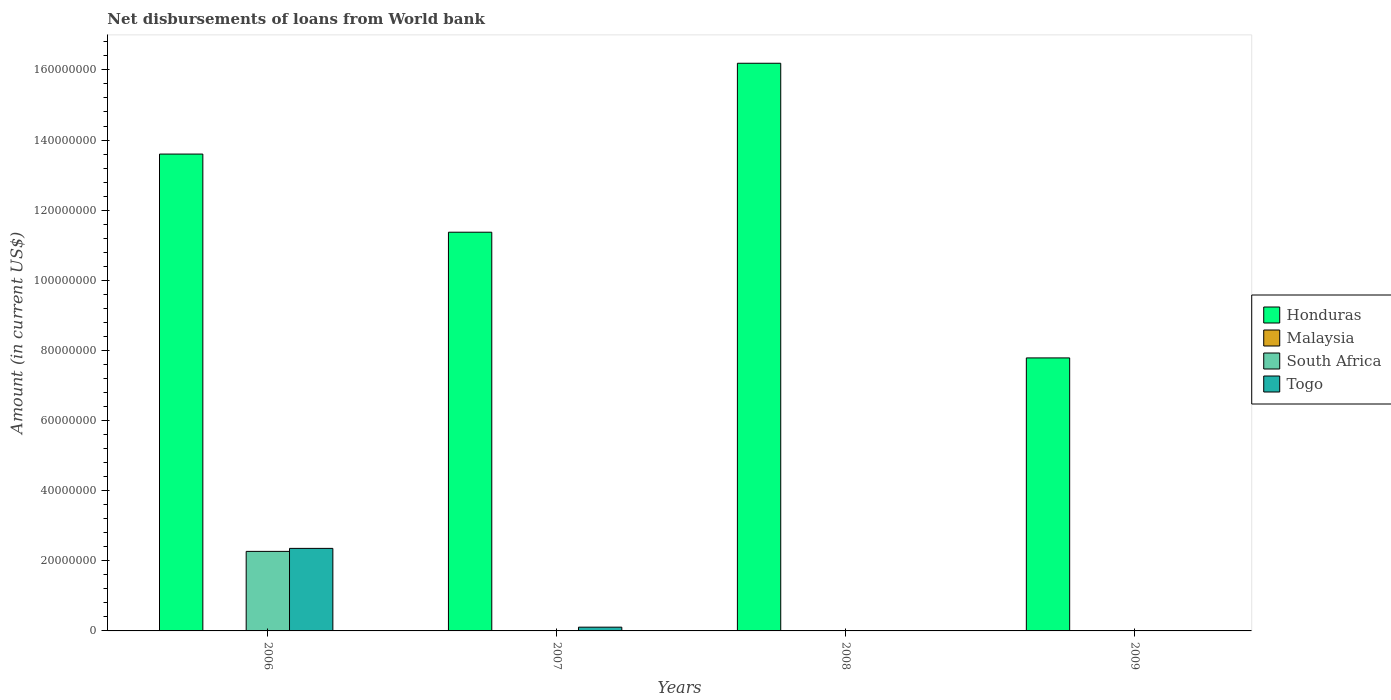Are the number of bars per tick equal to the number of legend labels?
Your answer should be compact. No. Are the number of bars on each tick of the X-axis equal?
Give a very brief answer. No. What is the label of the 1st group of bars from the left?
Keep it short and to the point. 2006. In how many cases, is the number of bars for a given year not equal to the number of legend labels?
Give a very brief answer. 4. What is the amount of loan disbursed from World Bank in Togo in 2008?
Offer a very short reply. 0. Across all years, what is the maximum amount of loan disbursed from World Bank in Honduras?
Keep it short and to the point. 1.62e+08. Across all years, what is the minimum amount of loan disbursed from World Bank in Honduras?
Make the answer very short. 7.79e+07. In which year was the amount of loan disbursed from World Bank in South Africa maximum?
Your answer should be compact. 2006. What is the total amount of loan disbursed from World Bank in Malaysia in the graph?
Offer a very short reply. 0. What is the difference between the amount of loan disbursed from World Bank in Honduras in 2006 and that in 2008?
Keep it short and to the point. -2.59e+07. What is the difference between the amount of loan disbursed from World Bank in Honduras in 2007 and the amount of loan disbursed from World Bank in Malaysia in 2008?
Your answer should be very brief. 1.14e+08. In the year 2006, what is the difference between the amount of loan disbursed from World Bank in South Africa and amount of loan disbursed from World Bank in Togo?
Offer a very short reply. -8.56e+05. What is the difference between the highest and the lowest amount of loan disbursed from World Bank in Togo?
Make the answer very short. 2.35e+07. Is the sum of the amount of loan disbursed from World Bank in Honduras in 2008 and 2009 greater than the maximum amount of loan disbursed from World Bank in South Africa across all years?
Make the answer very short. Yes. Is it the case that in every year, the sum of the amount of loan disbursed from World Bank in Togo and amount of loan disbursed from World Bank in South Africa is greater than the amount of loan disbursed from World Bank in Honduras?
Provide a succinct answer. No. How many bars are there?
Your answer should be very brief. 7. Are all the bars in the graph horizontal?
Your answer should be compact. No. How many years are there in the graph?
Offer a terse response. 4. What is the difference between two consecutive major ticks on the Y-axis?
Provide a short and direct response. 2.00e+07. How are the legend labels stacked?
Your response must be concise. Vertical. What is the title of the graph?
Offer a very short reply. Net disbursements of loans from World bank. What is the label or title of the X-axis?
Your answer should be compact. Years. What is the label or title of the Y-axis?
Ensure brevity in your answer.  Amount (in current US$). What is the Amount (in current US$) of Honduras in 2006?
Give a very brief answer. 1.36e+08. What is the Amount (in current US$) in South Africa in 2006?
Your answer should be compact. 2.27e+07. What is the Amount (in current US$) in Togo in 2006?
Provide a short and direct response. 2.35e+07. What is the Amount (in current US$) in Honduras in 2007?
Give a very brief answer. 1.14e+08. What is the Amount (in current US$) of Togo in 2007?
Your answer should be very brief. 1.07e+06. What is the Amount (in current US$) of Honduras in 2008?
Your answer should be compact. 1.62e+08. What is the Amount (in current US$) of Togo in 2008?
Offer a terse response. 0. What is the Amount (in current US$) in Honduras in 2009?
Keep it short and to the point. 7.79e+07. What is the Amount (in current US$) of Malaysia in 2009?
Offer a very short reply. 0. What is the Amount (in current US$) of South Africa in 2009?
Your response must be concise. 0. What is the Amount (in current US$) in Togo in 2009?
Your answer should be very brief. 0. Across all years, what is the maximum Amount (in current US$) of Honduras?
Offer a terse response. 1.62e+08. Across all years, what is the maximum Amount (in current US$) of South Africa?
Give a very brief answer. 2.27e+07. Across all years, what is the maximum Amount (in current US$) in Togo?
Your answer should be very brief. 2.35e+07. Across all years, what is the minimum Amount (in current US$) in Honduras?
Give a very brief answer. 7.79e+07. Across all years, what is the minimum Amount (in current US$) of South Africa?
Give a very brief answer. 0. What is the total Amount (in current US$) of Honduras in the graph?
Give a very brief answer. 4.89e+08. What is the total Amount (in current US$) in Malaysia in the graph?
Ensure brevity in your answer.  0. What is the total Amount (in current US$) of South Africa in the graph?
Provide a short and direct response. 2.27e+07. What is the total Amount (in current US$) of Togo in the graph?
Ensure brevity in your answer.  2.46e+07. What is the difference between the Amount (in current US$) in Honduras in 2006 and that in 2007?
Offer a very short reply. 2.23e+07. What is the difference between the Amount (in current US$) in Togo in 2006 and that in 2007?
Your answer should be very brief. 2.25e+07. What is the difference between the Amount (in current US$) in Honduras in 2006 and that in 2008?
Keep it short and to the point. -2.59e+07. What is the difference between the Amount (in current US$) in Honduras in 2006 and that in 2009?
Your answer should be very brief. 5.81e+07. What is the difference between the Amount (in current US$) in Honduras in 2007 and that in 2008?
Your response must be concise. -4.82e+07. What is the difference between the Amount (in current US$) in Honduras in 2007 and that in 2009?
Give a very brief answer. 3.59e+07. What is the difference between the Amount (in current US$) in Honduras in 2008 and that in 2009?
Ensure brevity in your answer.  8.40e+07. What is the difference between the Amount (in current US$) in Honduras in 2006 and the Amount (in current US$) in Togo in 2007?
Give a very brief answer. 1.35e+08. What is the difference between the Amount (in current US$) of South Africa in 2006 and the Amount (in current US$) of Togo in 2007?
Give a very brief answer. 2.16e+07. What is the average Amount (in current US$) in Honduras per year?
Provide a succinct answer. 1.22e+08. What is the average Amount (in current US$) in Malaysia per year?
Give a very brief answer. 0. What is the average Amount (in current US$) of South Africa per year?
Ensure brevity in your answer.  5.67e+06. What is the average Amount (in current US$) in Togo per year?
Your answer should be compact. 6.15e+06. In the year 2006, what is the difference between the Amount (in current US$) of Honduras and Amount (in current US$) of South Africa?
Your answer should be very brief. 1.13e+08. In the year 2006, what is the difference between the Amount (in current US$) of Honduras and Amount (in current US$) of Togo?
Ensure brevity in your answer.  1.12e+08. In the year 2006, what is the difference between the Amount (in current US$) of South Africa and Amount (in current US$) of Togo?
Provide a short and direct response. -8.56e+05. In the year 2007, what is the difference between the Amount (in current US$) in Honduras and Amount (in current US$) in Togo?
Your answer should be very brief. 1.13e+08. What is the ratio of the Amount (in current US$) of Honduras in 2006 to that in 2007?
Your answer should be compact. 1.2. What is the ratio of the Amount (in current US$) in Togo in 2006 to that in 2007?
Keep it short and to the point. 21.94. What is the ratio of the Amount (in current US$) of Honduras in 2006 to that in 2008?
Your answer should be very brief. 0.84. What is the ratio of the Amount (in current US$) of Honduras in 2006 to that in 2009?
Provide a short and direct response. 1.75. What is the ratio of the Amount (in current US$) of Honduras in 2007 to that in 2008?
Give a very brief answer. 0.7. What is the ratio of the Amount (in current US$) of Honduras in 2007 to that in 2009?
Keep it short and to the point. 1.46. What is the ratio of the Amount (in current US$) in Honduras in 2008 to that in 2009?
Keep it short and to the point. 2.08. What is the difference between the highest and the second highest Amount (in current US$) in Honduras?
Offer a terse response. 2.59e+07. What is the difference between the highest and the lowest Amount (in current US$) in Honduras?
Ensure brevity in your answer.  8.40e+07. What is the difference between the highest and the lowest Amount (in current US$) of South Africa?
Make the answer very short. 2.27e+07. What is the difference between the highest and the lowest Amount (in current US$) of Togo?
Offer a terse response. 2.35e+07. 